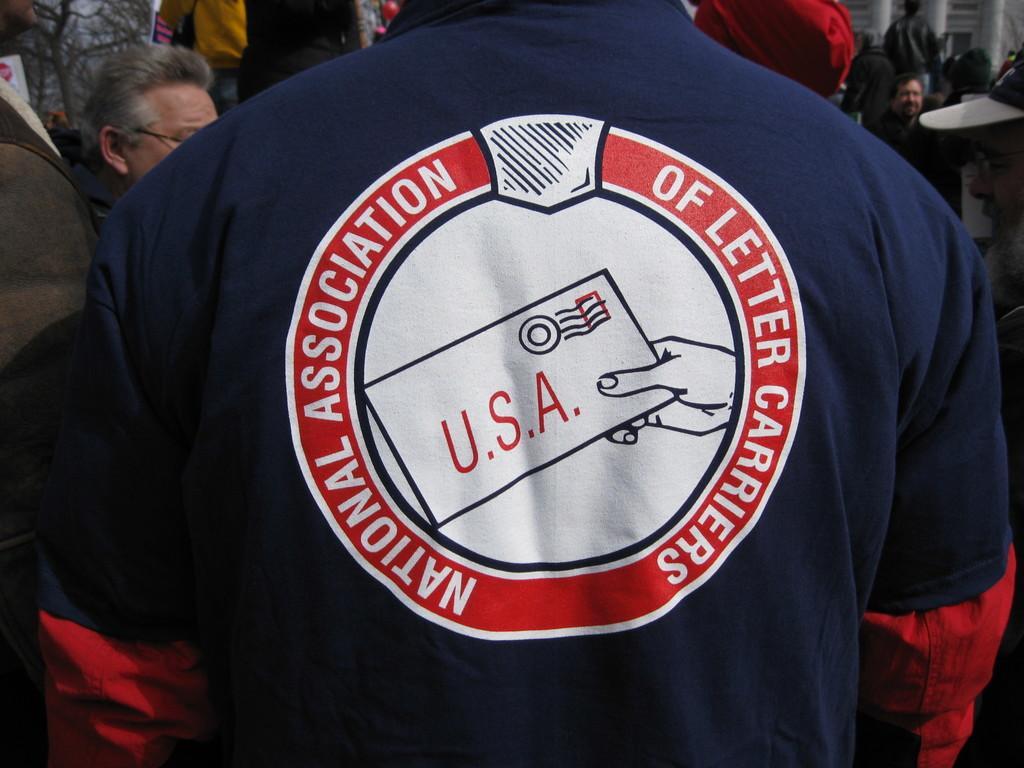How would you summarize this image in a sentence or two? In this image we can see a man standing wearing a t-shirt having some text on it. On the backside we can see a group of people, some pillars and a tree. 